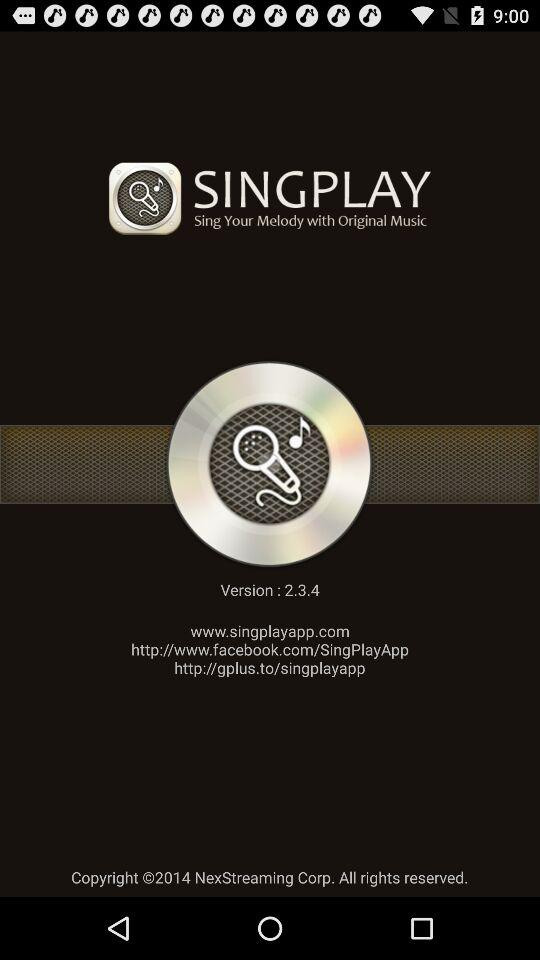What version is used? The version is 2.3.4. 